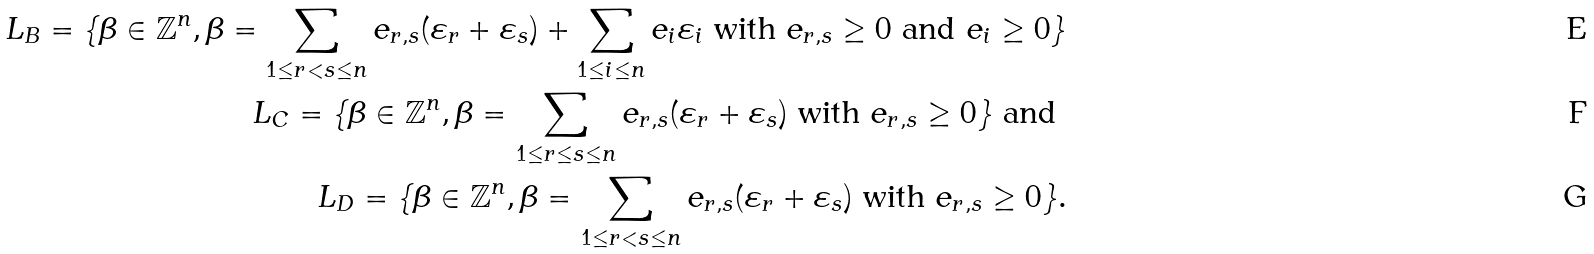<formula> <loc_0><loc_0><loc_500><loc_500>L _ { B } = \{ \beta \in \mathbb { Z } ^ { n } , \beta = \sum _ { 1 \leq r < s \leq n } e _ { r , s } ( \varepsilon _ { r } + \varepsilon _ { s } ) + \sum _ { 1 \leq i \leq n } e _ { i } \varepsilon _ { i } \text { with } e _ { r , s } \geq 0 \text { and } e _ { i } \geq 0 \} \\ L _ { C } = \{ \beta \in \mathbb { Z } ^ { n } , \beta = \sum _ { 1 \leq r \leq s \leq n } e _ { r , s } ( \varepsilon _ { r } + \varepsilon _ { s } ) \text { with } e _ { r , s } \geq 0 \} \text { and } \\ L _ { D } = \{ \beta \in \mathbb { Z } ^ { n } , \beta = \sum _ { 1 \leq r < s \leq n } e _ { r , s } ( \varepsilon _ { r } + \varepsilon _ { s } ) \text { with } e _ { r , s } \geq 0 \} .</formula> 